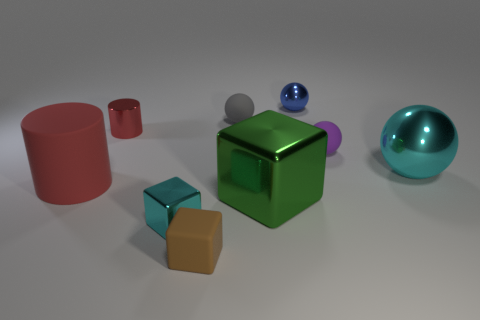Subtract all tiny blue metal spheres. How many spheres are left? 3 Subtract all cyan cubes. How many cubes are left? 2 Add 1 small brown rubber cubes. How many objects exist? 10 Subtract 2 cylinders. How many cylinders are left? 0 Subtract all cylinders. How many objects are left? 7 Subtract all cyan blocks. Subtract all purple cylinders. How many blocks are left? 2 Subtract all purple spheres. How many cyan blocks are left? 1 Subtract all tiny purple metallic things. Subtract all tiny purple rubber balls. How many objects are left? 8 Add 3 small cyan shiny things. How many small cyan shiny things are left? 4 Add 1 blue shiny things. How many blue shiny things exist? 2 